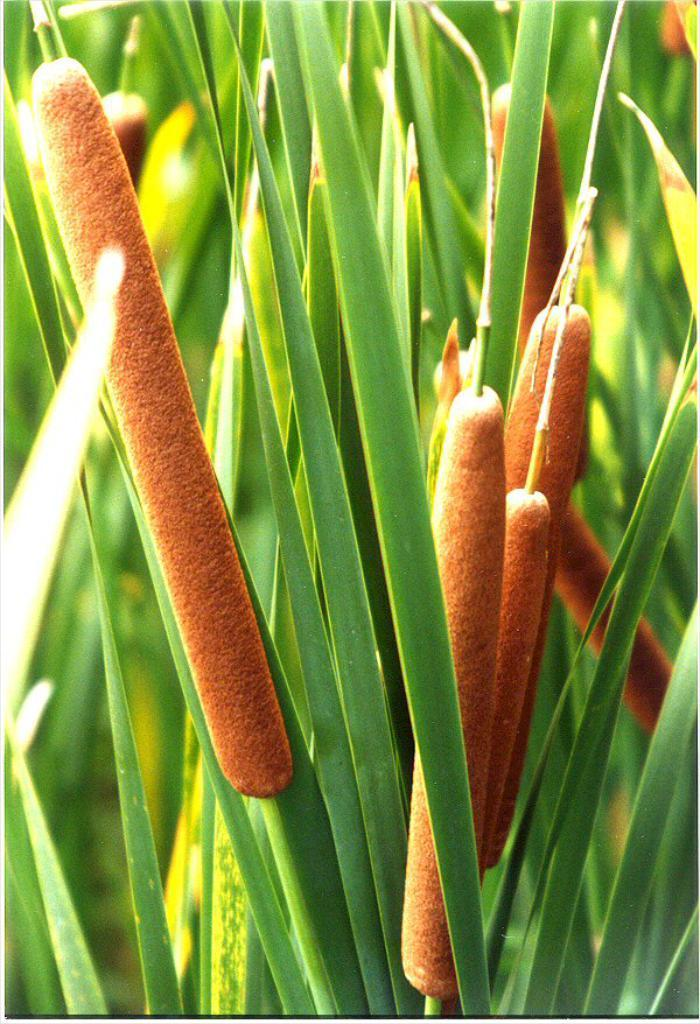What type of vegetation is present in the image? There is grass in the image. What color can be observed in some of the objects in the image? Some objects in the image are orange in color. Can you see any snow in the image? No, there is no snow present in the image. Is there a person visible in the image? There is no person mentioned or visible in the image. 